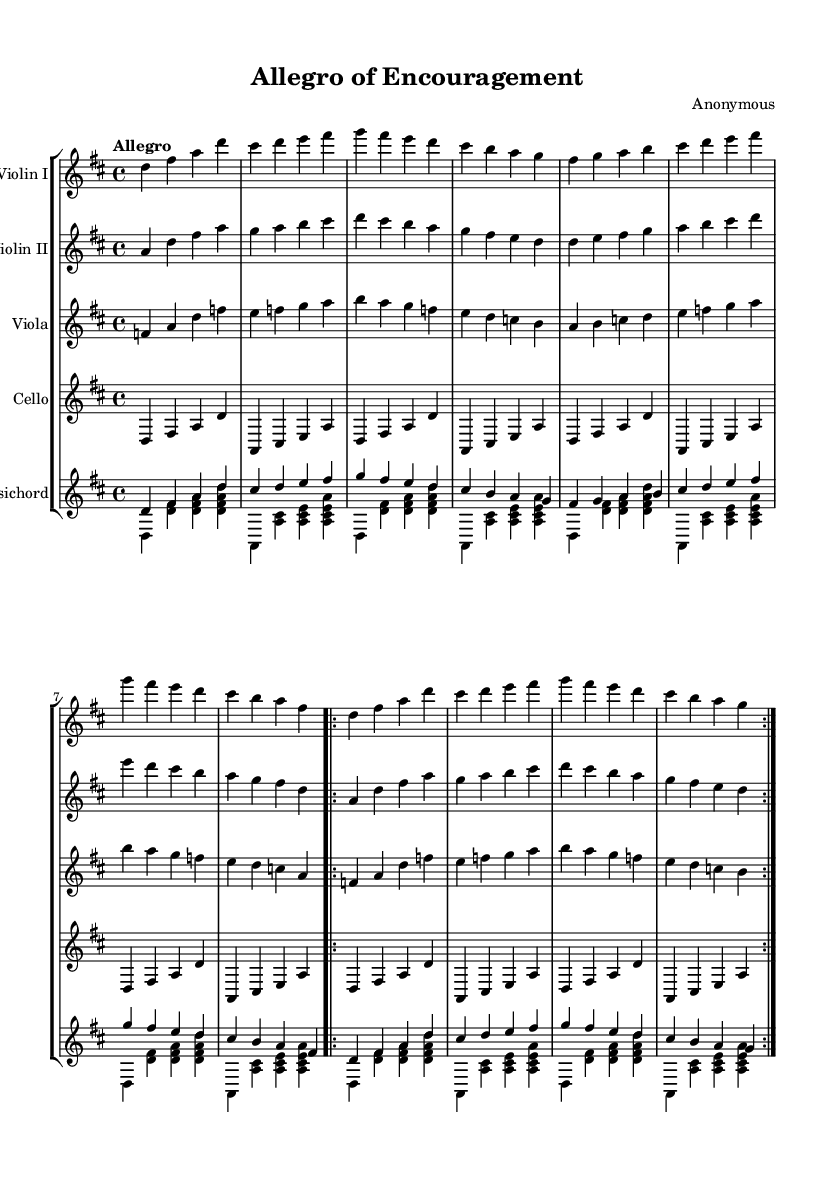What is the key signature of this music? The key signature is D major, which has two sharps (F# and C#). We can identify this by looking at the beginning of the staff where the sharps are indicated.
Answer: D major What is the time signature of this music? The time signature is 4/4, which indicates that there are four beats in each measure and the quarter note gets one beat. This is visible at the beginning of the score just after the key signature.
Answer: 4/4 What is the tempo marking for this piece? The tempo marking is "Allegro", which refers to a fast and lively pace. This is found at the beginning of the score right after the time signature.
Answer: Allegro How many measures are in the first section of the piece? The first section of the piece contains 8 measures, as it consists of two complete sections of 4 measures each before it repeats. By counting the measures in the score, we see that the first repeated section ends after 8 units.
Answer: 8 What instruments are involved in this piece? The instruments in this piece are Violin I, Violin II, Viola, Cello, and Harpsichord. Each instrument is indicated on a separate staff, and they are all labeled at the start of each line in the score.
Answer: Violin I, Violin II, Viola, Cello, Harpsichord What type of musical form is evident in this piece? The musical form evident in this piece is a binary form, characterized by the repeated A sections. This is indicated by the notation showing repeated sections with the volta markers for reconstruction.
Answer: Binary form Which characteristic ornamentation might be expected in Baroque music? A characteristic ornamentation that might be expected in Baroque music is the use of trills. Although trills aren't explicitly shown in this excerpt, they are common in Baroque compositions and can be implied in the performance.
Answer: Trills 